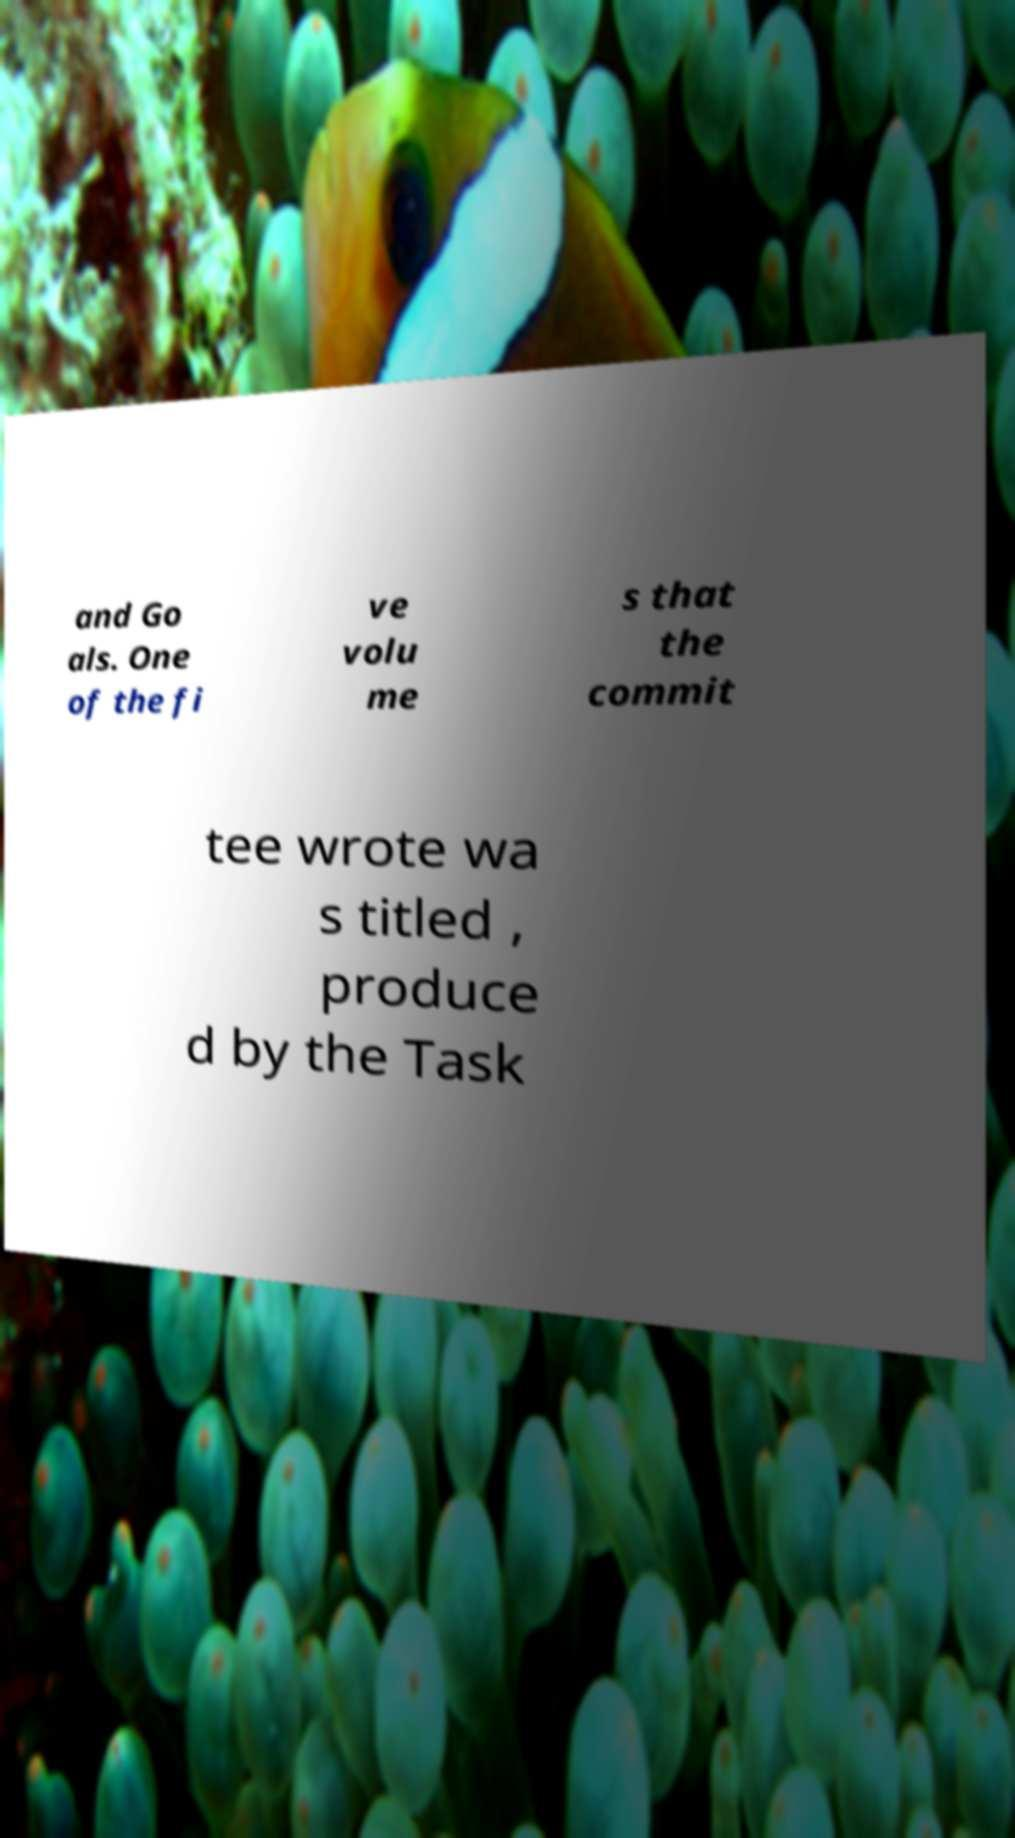Can you accurately transcribe the text from the provided image for me? and Go als. One of the fi ve volu me s that the commit tee wrote wa s titled , produce d by the Task 